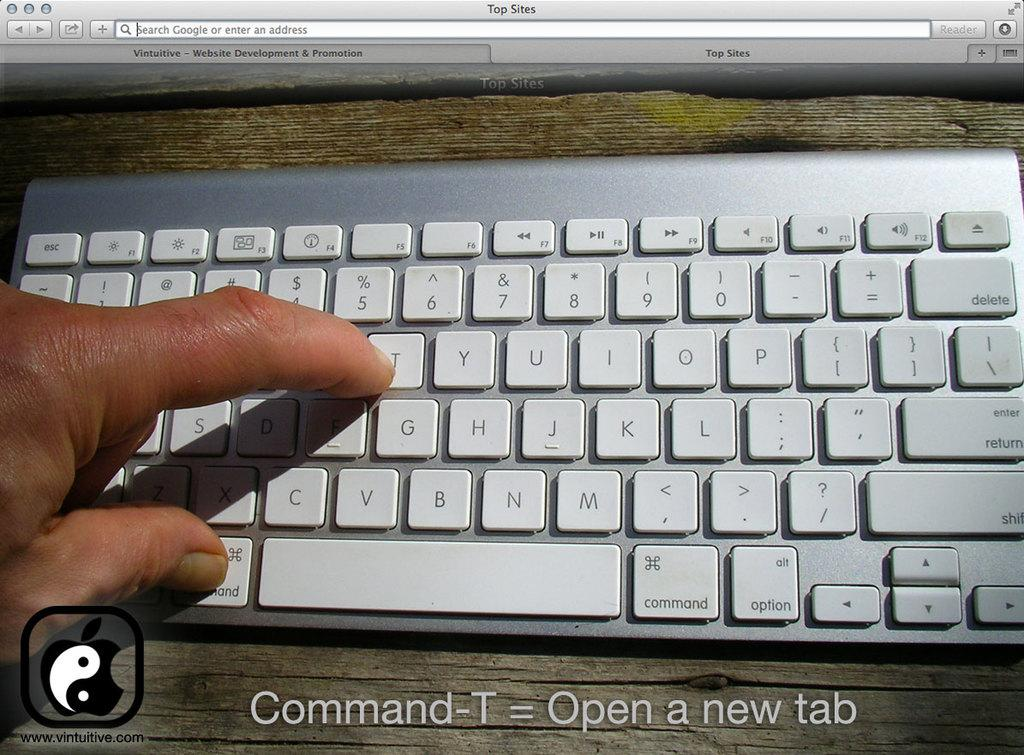<image>
Provide a brief description of the given image. A person demonstrating on a keyboard the Command-T function that opens a new tab. 